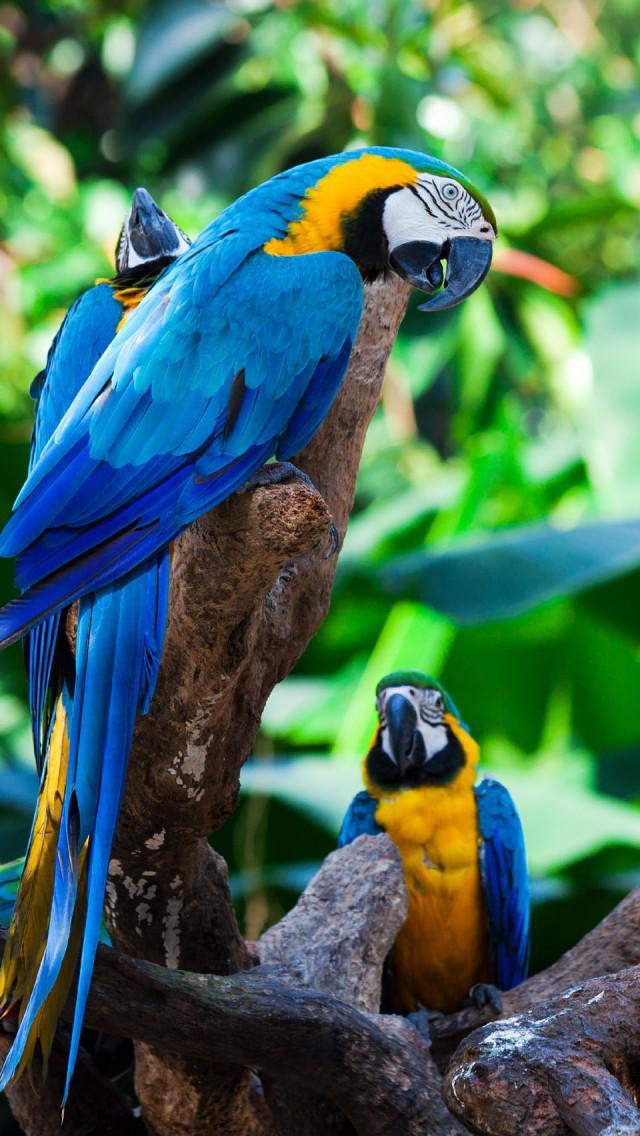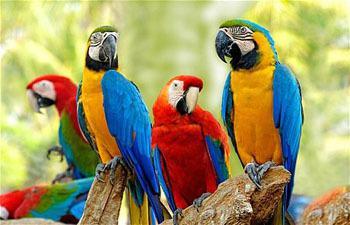The first image is the image on the left, the second image is the image on the right. Considering the images on both sides, is "The right image contains a single bird." valid? Answer yes or no. No. 